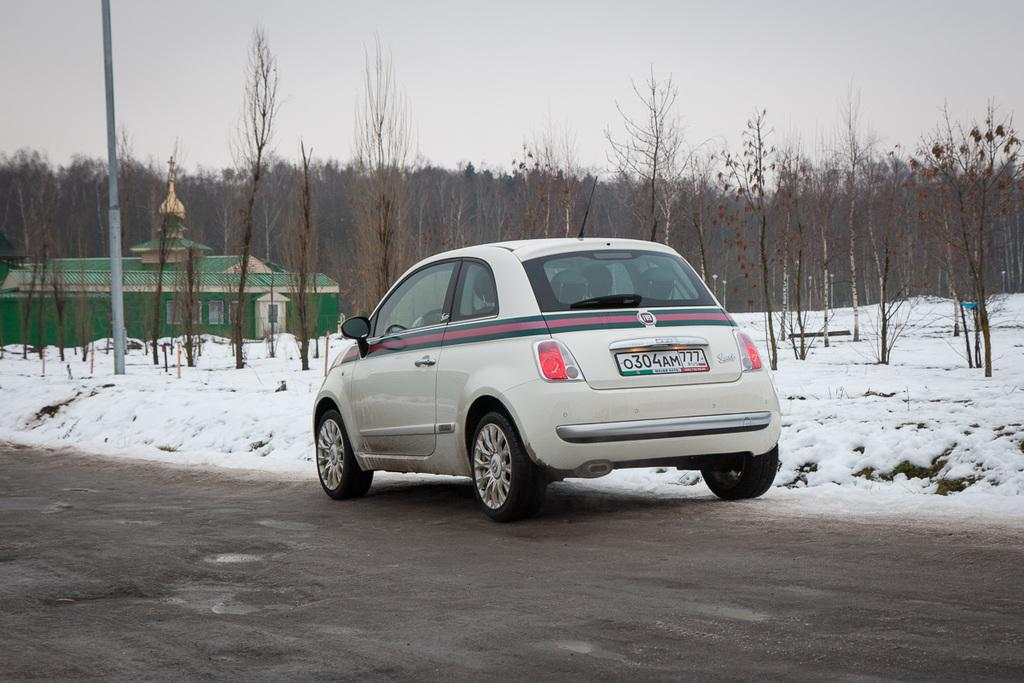What is the main subject of the image? There is a car in the image. What is the car doing in the image? The car is moving on the road. What can be seen in the background of the image? There are trees and a building in the background of the image. What is the condition of the ground in the image? There is snow on the ground. What type of juice is being served on the table in the image? There is no table or juice present in the image; it features a moving car on a snowy road with trees and a building in the background. 